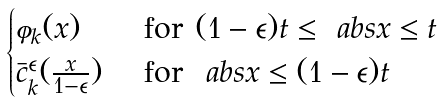<formula> <loc_0><loc_0><loc_500><loc_500>\begin{cases} \varphi _ { k } ( x ) & \text { for } ( 1 - \epsilon ) t \leq \ a b s { x } \leq t \\ \bar { c } _ { k } ^ { \epsilon } ( \frac { x } { 1 - \epsilon } ) & \text { for } \ a b s { x } \leq ( 1 - \epsilon ) t \end{cases}</formula> 